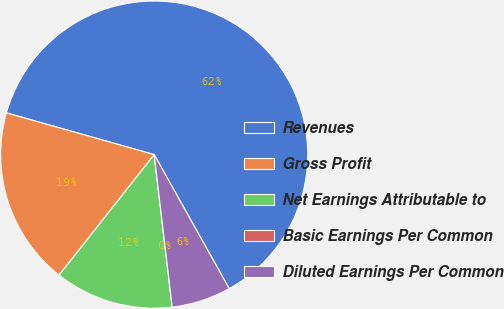<chart> <loc_0><loc_0><loc_500><loc_500><pie_chart><fcel>Revenues<fcel>Gross Profit<fcel>Net Earnings Attributable to<fcel>Basic Earnings Per Common<fcel>Diluted Earnings Per Common<nl><fcel>62.5%<fcel>18.75%<fcel>12.5%<fcel>0.0%<fcel>6.25%<nl></chart> 